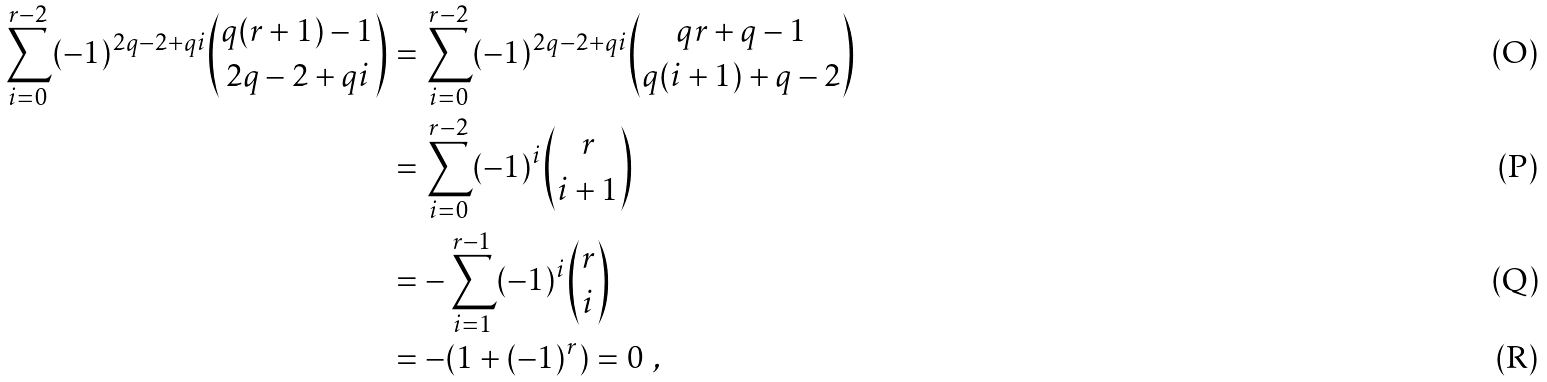<formula> <loc_0><loc_0><loc_500><loc_500>\sum _ { i = 0 } ^ { r - 2 } ( - 1 ) ^ { 2 q - 2 + q i } \binom { q ( r + 1 ) - 1 } { 2 q - 2 + q i } & = \sum _ { i = 0 } ^ { r - 2 } ( - 1 ) ^ { 2 q - 2 + q i } \binom { q r + q - 1 } { q ( i + 1 ) + q - 2 } \\ & = \sum _ { i = 0 } ^ { r - 2 } ( - 1 ) ^ { i } \binom { r } { i + 1 } \\ & = - \sum _ { i = 1 } ^ { r - 1 } ( - 1 ) ^ { i } \binom { r } { i } \\ & = - ( 1 + ( - 1 ) ^ { r } ) = 0 \ ,</formula> 